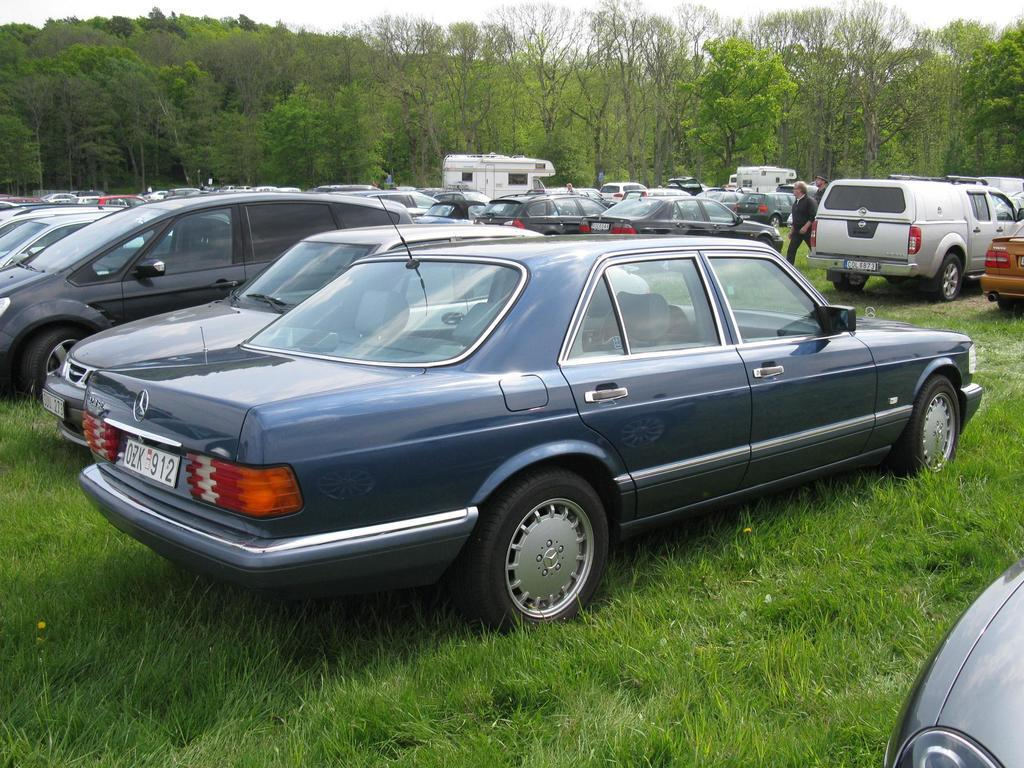<image>
Share a concise interpretation of the image provided. A Mercedes with a tag that reads OZK 912. 